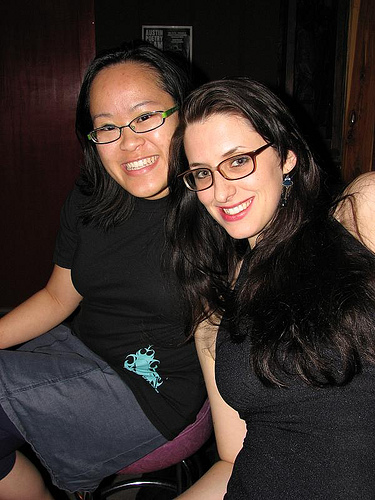<image>
Can you confirm if the glasses is on the woman? No. The glasses is not positioned on the woman. They may be near each other, but the glasses is not supported by or resting on top of the woman. 